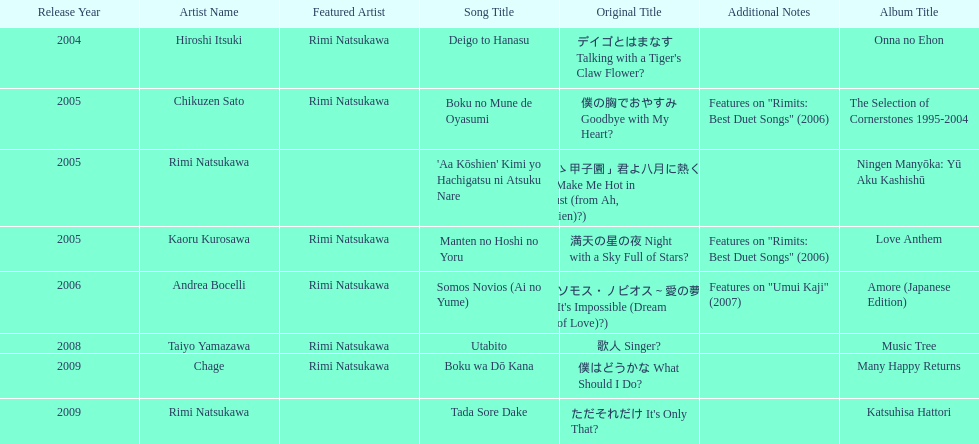Which was not released in 2004, onna no ehon or music tree? Music Tree. 